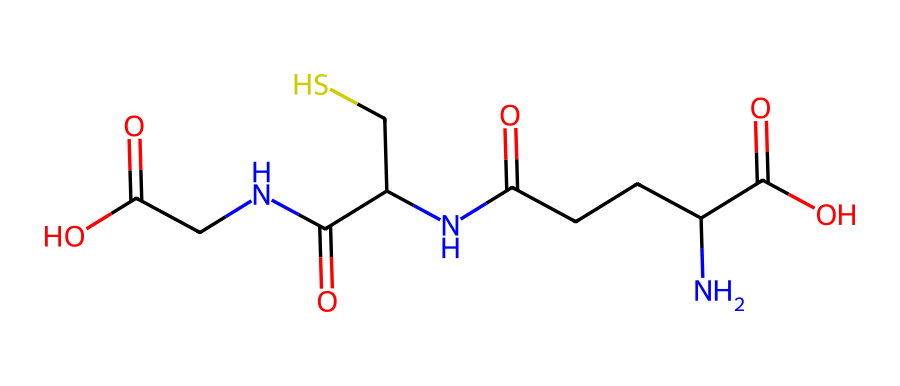What is the primary functional group present in this molecule? The molecule has multiple functional groups, but the primary one is the amine group (–NH2), which can be identified by the nitrogen atom attached to hydrogen atoms.
Answer: amine How many sulfur atoms are present in this compound? In the provided SMILES representation, there is one instance of "S," indicating the presence of one sulfur atom in the structure.
Answer: one What type of bonds are formed between carbon and sulfur in this compound? The bond between carbon and sulfur is typically a single bond, as indicated by the structure where carbon is directly connected to the sulfur atom.
Answer: single bond Identify the number of carbon atoms in the molecule. By analyzing the SMILES representation, we can count the number of carbon atoms; there are 7 carbon atoms represented in the structure.
Answer: seven What type of compound is glutathione considered to be? Glutathione is classified as a tripeptide because it consists of three amino acids linked together by peptide bonds, making it a type of small protein-like compound.
Answer: tripeptide What role does glutathione play in cellular processes? Glutathione primarily acts as an antioxidant, helping to protect cells from oxidative stress by neutralizing free radicals and reactive oxygen species.
Answer: antioxidant 